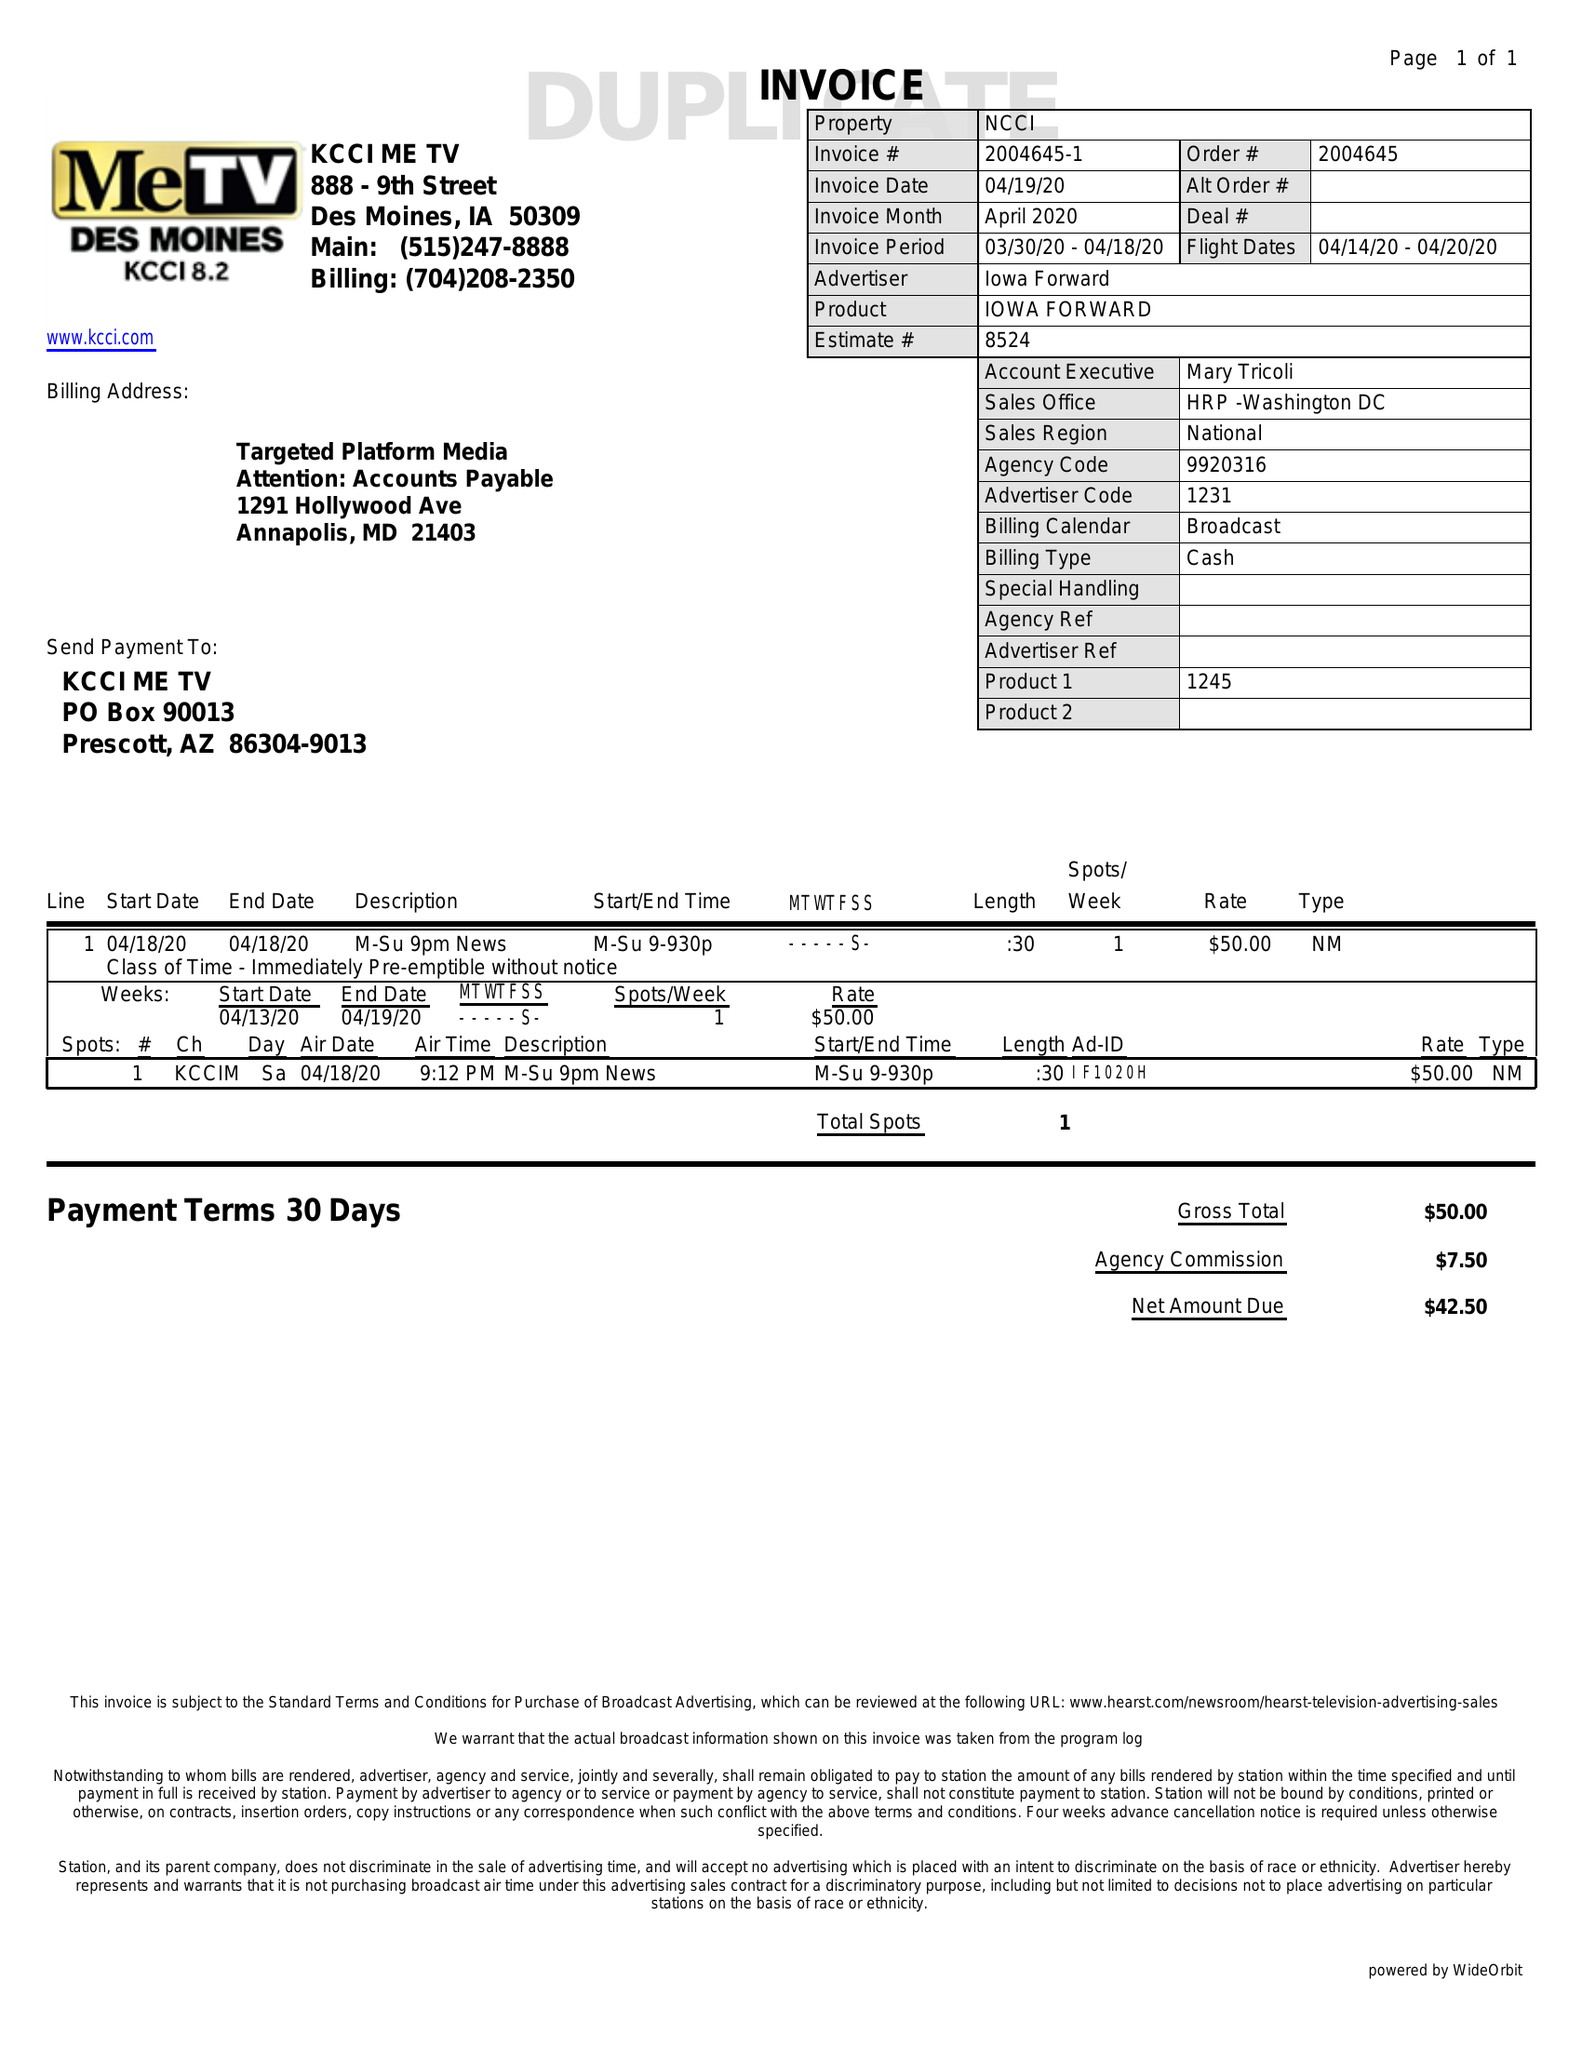What is the value for the advertiser?
Answer the question using a single word or phrase. IOWA FORWARD 